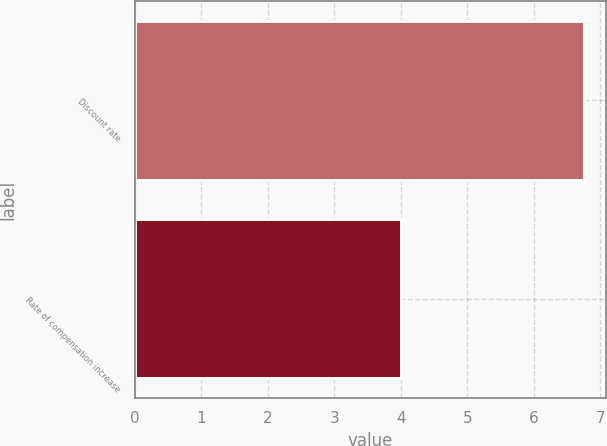Convert chart. <chart><loc_0><loc_0><loc_500><loc_500><bar_chart><fcel>Discount rate<fcel>Rate of compensation increase<nl><fcel>6.75<fcel>4<nl></chart> 